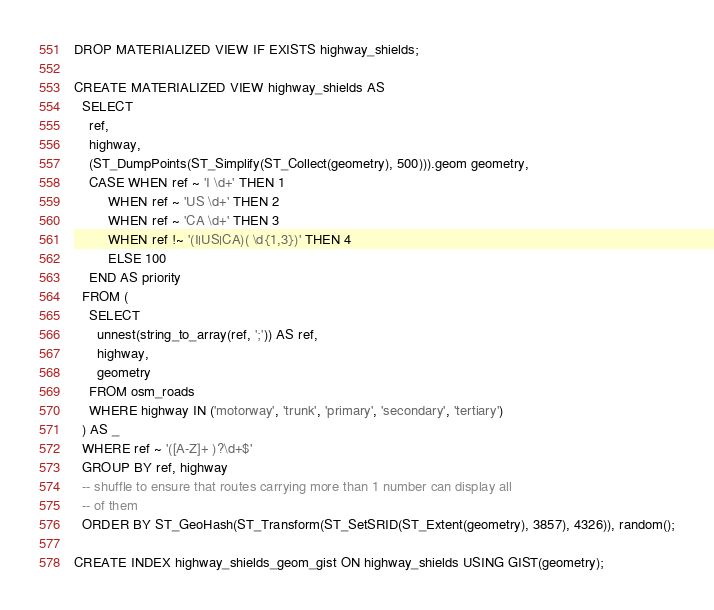Convert code to text. <code><loc_0><loc_0><loc_500><loc_500><_SQL_>DROP MATERIALIZED VIEW IF EXISTS highway_shields;

CREATE MATERIALIZED VIEW highway_shields AS
  SELECT
    ref,
    highway,
    (ST_DumpPoints(ST_Simplify(ST_Collect(geometry), 500))).geom geometry,
    CASE WHEN ref ~ 'I \d+' THEN 1
         WHEN ref ~ 'US \d+' THEN 2
         WHEN ref ~ 'CA \d+' THEN 3
         WHEN ref !~ '(I|US|CA)( \d{1,3})' THEN 4
         ELSE 100
    END AS priority
  FROM (
    SELECT
      unnest(string_to_array(ref, ';')) AS ref,
      highway,
      geometry
    FROM osm_roads
    WHERE highway IN ('motorway', 'trunk', 'primary', 'secondary', 'tertiary')
  ) AS _
  WHERE ref ~ '([A-Z]+ )?\d+$'
  GROUP BY ref, highway
  -- shuffle to ensure that routes carrying more than 1 number can display all
  -- of them
  ORDER BY ST_GeoHash(ST_Transform(ST_SetSRID(ST_Extent(geometry), 3857), 4326)), random();

CREATE INDEX highway_shields_geom_gist ON highway_shields USING GIST(geometry);
</code> 